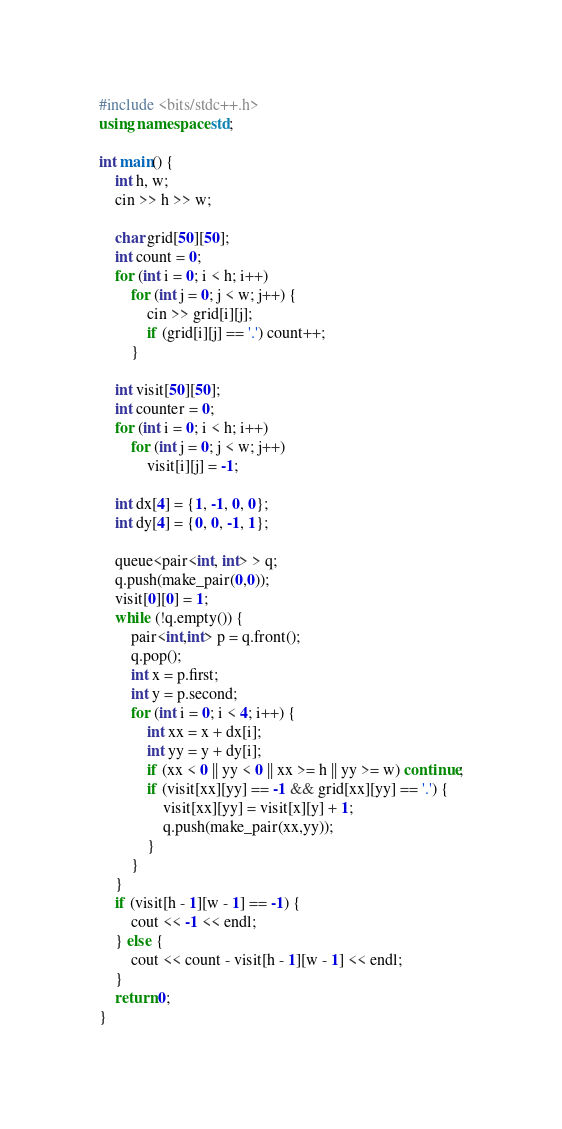Convert code to text. <code><loc_0><loc_0><loc_500><loc_500><_C++_>#include <bits/stdc++.h>
using namespace std;

int main() {
    int h, w;
    cin >> h >> w;

    char grid[50][50];
    int count = 0;
    for (int i = 0; i < h; i++)
        for (int j = 0; j < w; j++) {
            cin >> grid[i][j];
            if (grid[i][j] == '.') count++;
        }

    int visit[50][50];
    int counter = 0;
    for (int i = 0; i < h; i++)
        for (int j = 0; j < w; j++)
            visit[i][j] = -1;

    int dx[4] = {1, -1, 0, 0};
    int dy[4] = {0, 0, -1, 1};
    
    queue<pair<int, int> > q;
    q.push(make_pair(0,0));
    visit[0][0] = 1;
    while (!q.empty()) {
        pair<int,int> p = q.front();
        q.pop();
        int x = p.first;
        int y = p.second;
        for (int i = 0; i < 4; i++) {
            int xx = x + dx[i];
            int yy = y + dy[i];
            if (xx < 0 || yy < 0 || xx >= h || yy >= w) continue;
            if (visit[xx][yy] == -1 && grid[xx][yy] == '.') {
                visit[xx][yy] = visit[x][y] + 1;
                q.push(make_pair(xx,yy));
            }
        }
    }
    if (visit[h - 1][w - 1] == -1) {
        cout << -1 << endl;
    } else {
        cout << count - visit[h - 1][w - 1] << endl;
    }
    return 0;
}
</code> 